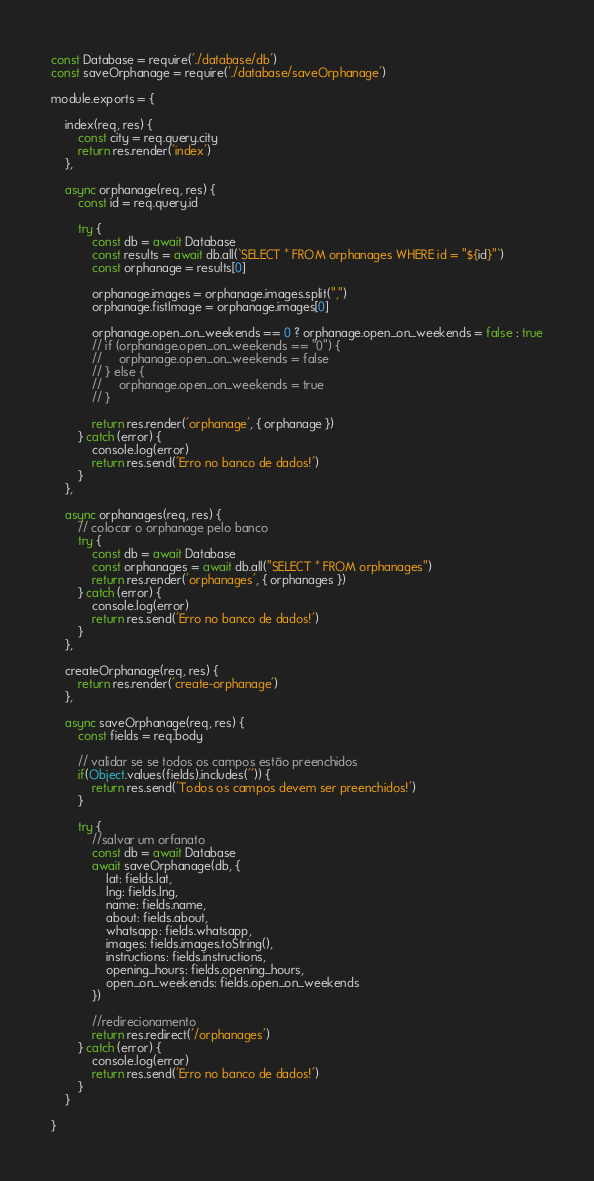Convert code to text. <code><loc_0><loc_0><loc_500><loc_500><_JavaScript_>const Database = require('./database/db')
const saveOrphanage = require('./database/saveOrphanage')

module.exports = {

    index(req, res) {
        const city = req.query.city
        return res.render('index')
    },

    async orphanage(req, res) {
        const id = req.query.id

        try {
            const db = await Database
            const results = await db.all(`SELECT * FROM orphanages WHERE id = "${id}"`)
            const orphanage = results[0]

            orphanage.images = orphanage.images.split(",")
            orphanage.fistImage = orphanage.images[0]

            orphanage.open_on_weekends == 0 ? orphanage.open_on_weekends = false : true
            // if (orphanage.open_on_weekends == "0") {
            //     orphanage.open_on_weekends = false
            // } else {
            //     orphanage.open_on_weekends = true
            // }

            return res.render('orphanage', { orphanage })
        } catch (error) {
            console.log(error)
            return res.send('Erro no banco de dados!')
        }
    },

    async orphanages(req, res) {
        // colocar o orphanage pelo banco
        try {
            const db = await Database
            const orphanages = await db.all("SELECT * FROM orphanages")
            return res.render('orphanages', { orphanages })
        } catch (error) {
            console.log(error)
            return res.send('Erro no banco de dados!')
        }
    },

    createOrphanage(req, res) {
        return res.render('create-orphanage')
    },

    async saveOrphanage(req, res) {
        const fields = req.body

        // validar se se todos os campos estão preenchidos
        if(Object.values(fields).includes('')) {
            return res.send('Todos os campos devem ser preenchidos!')
        }

        try {
            //salvar um orfanato
            const db = await Database
            await saveOrphanage(db, {
                lat: fields.lat,
                lng: fields.lng,
                name: fields.name,
                about: fields.about,
                whatsapp: fields.whatsapp,
                images: fields.images.toString(),
                instructions: fields.instructions,
                opening_hours: fields.opening_hours,
                open_on_weekends: fields.open_on_weekends
            })

            //redirecionamento
            return res.redirect('/orphanages')
        } catch (error) {
            console.log(error)
            return res.send('Erro no banco de dados!')
        }
    }

}</code> 